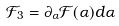Convert formula to latex. <formula><loc_0><loc_0><loc_500><loc_500>\mathcal { F } _ { 3 } = \partial _ { \alpha } \mathcal { F } ( \alpha ) d \alpha</formula> 